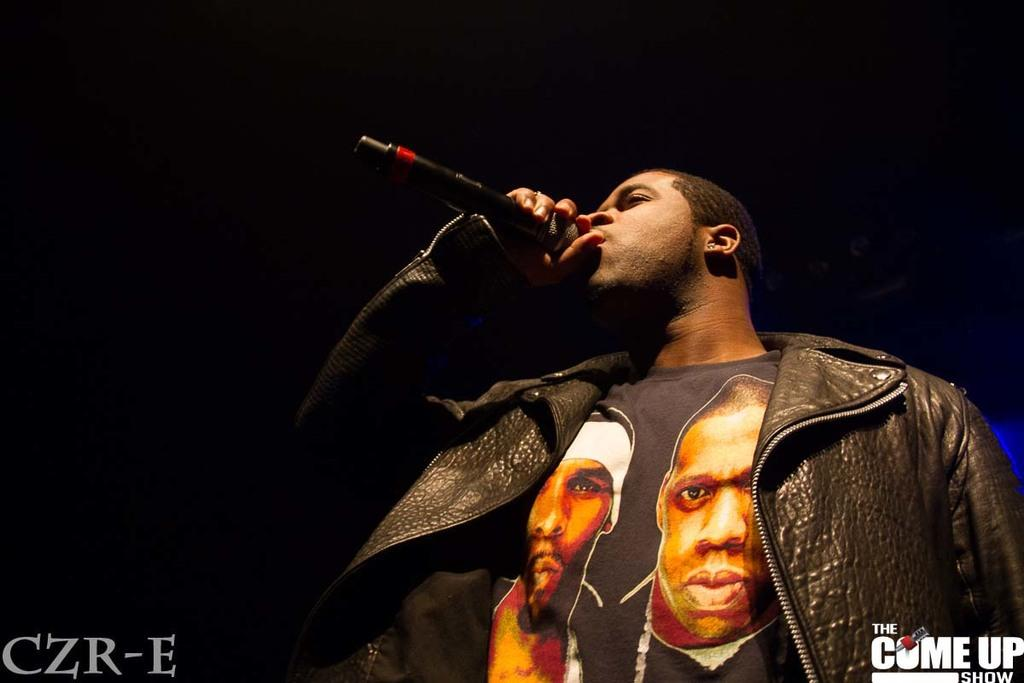What is the main subject of the image? There is a man in the image. What is the man holding in the image? The man is holding a microphone. What is the man's posture in the image? The man is standing in the image. What color is the background of the image? The background of the image is black. What else can be seen in the image besides the man? There is text visible in the image. How many feet of rainfall are expected during the rainstorm depicted in the image? There is no rainstorm depicted in the image; it features a man holding a microphone with a black background and visible text. 